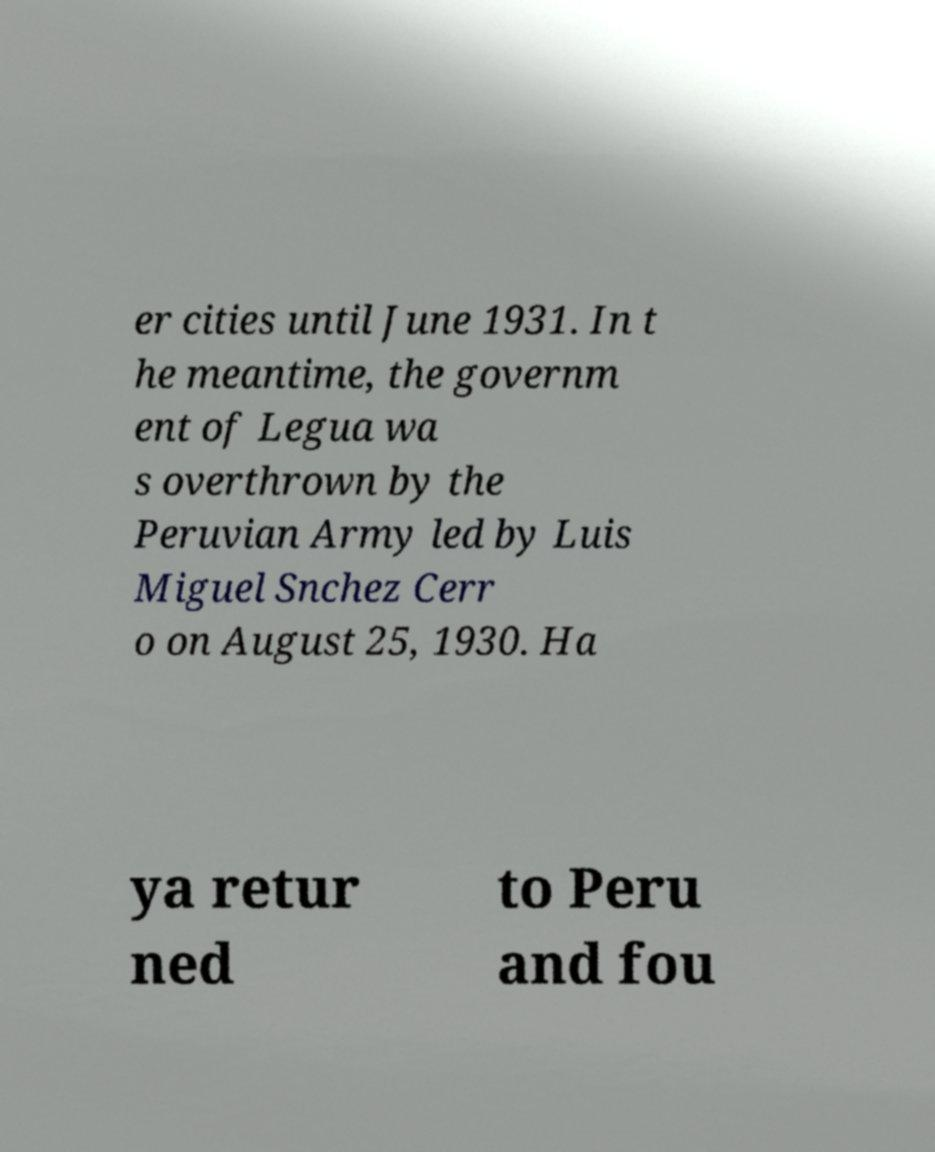Please identify and transcribe the text found in this image. er cities until June 1931. In t he meantime, the governm ent of Legua wa s overthrown by the Peruvian Army led by Luis Miguel Snchez Cerr o on August 25, 1930. Ha ya retur ned to Peru and fou 